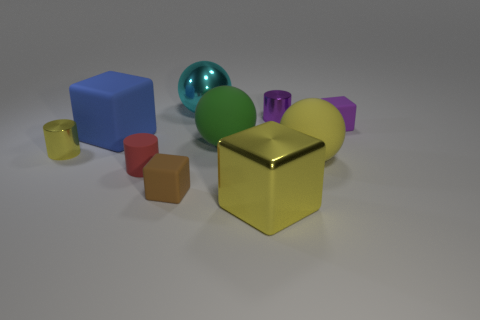Subtract all green cylinders. Subtract all blue balls. How many cylinders are left? 3 Subtract all spheres. How many objects are left? 7 Subtract all large metal balls. Subtract all tiny red matte things. How many objects are left? 8 Add 4 green matte spheres. How many green matte spheres are left? 5 Add 5 large rubber balls. How many large rubber balls exist? 7 Subtract 0 blue spheres. How many objects are left? 10 